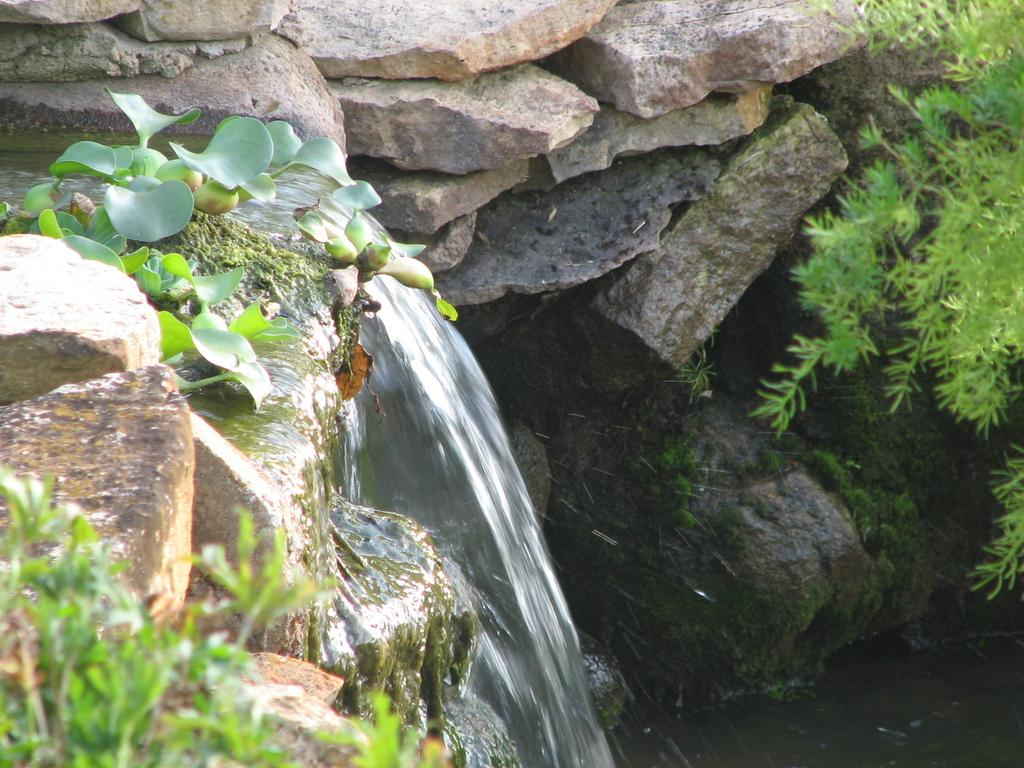What type of vegetation can be seen in the image? There are green leaves and tiny plants in the image. What is covering the rocks in the image? There is a formation of algae on the rocks in the image. What is the primary liquid visible in the image? There is water visible in the image. What type of natural formation can be seen in the image? There are rocks in the image. What type of oven is used to cook the algae in the image? There is no oven present in the image, and the algae is not being cooked. What experience can be gained from observing the tiny plants in the image? The image does not convey any specific experience, as it is a static representation of the scene. 